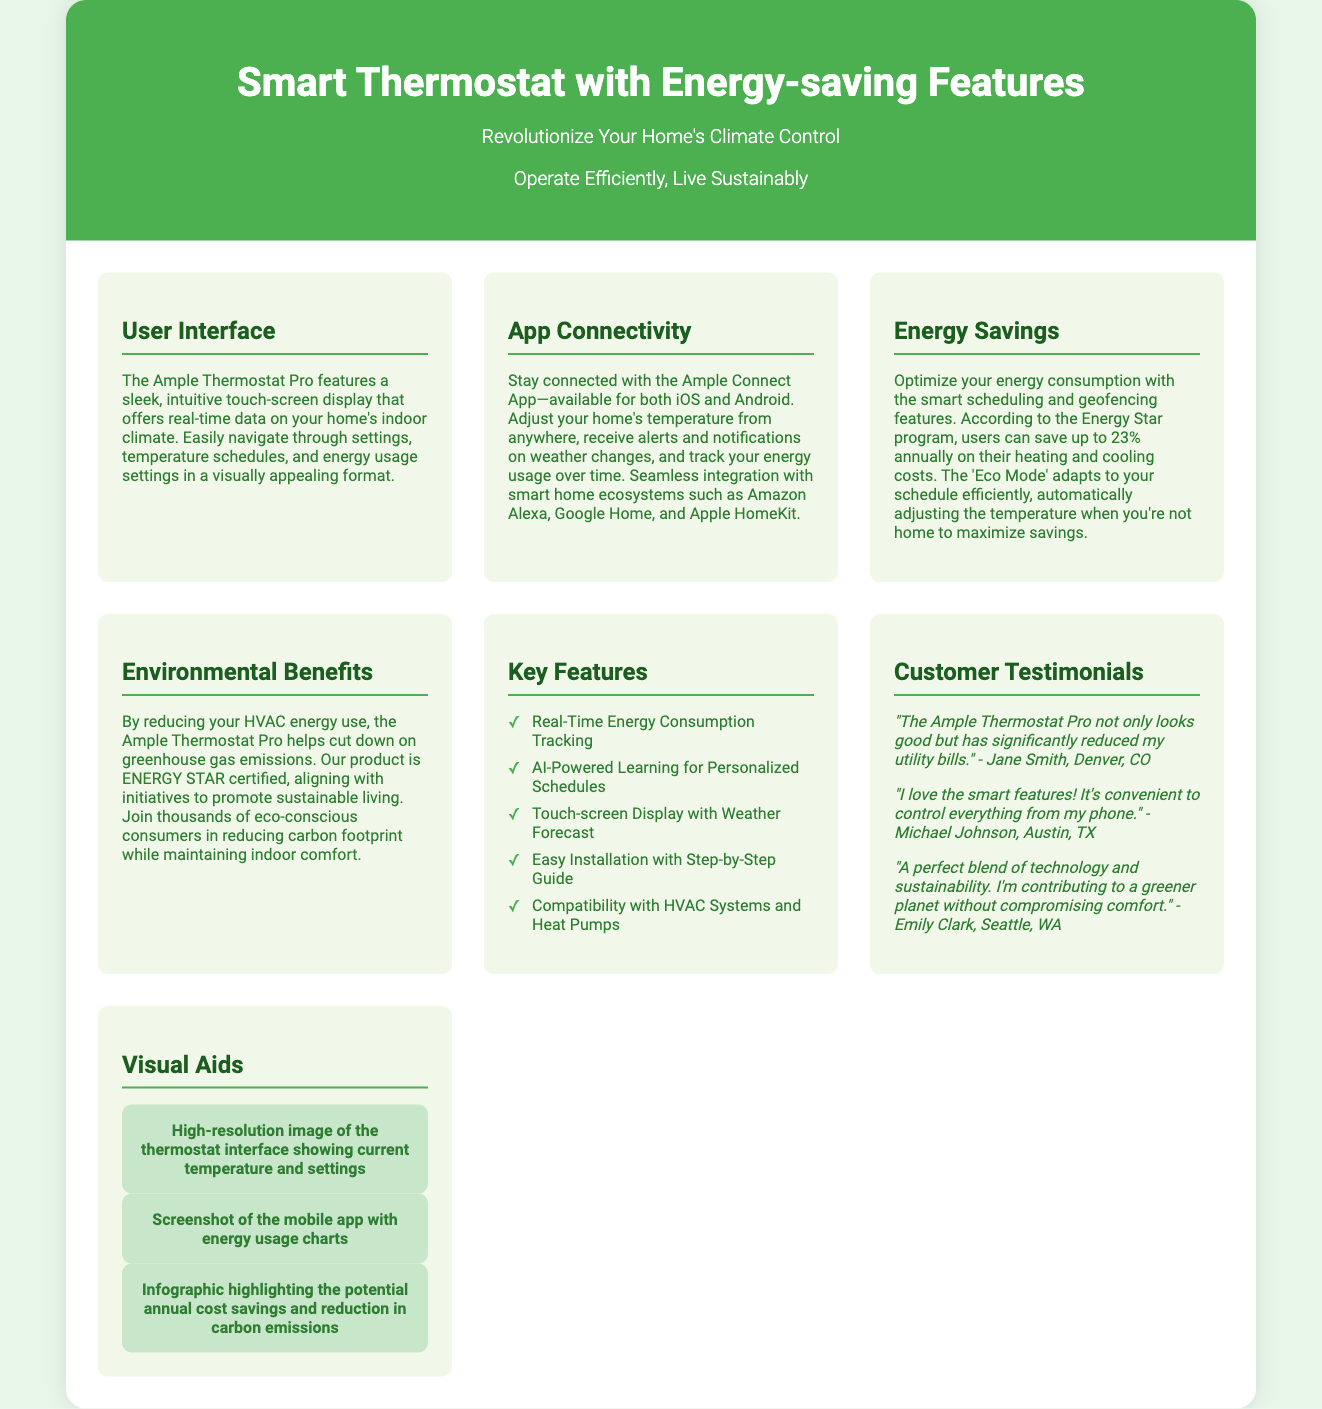What is the name of the product? The name of the product is located at the top of the document under the title.
Answer: Smart Thermostat with Energy-saving Features What mobile platforms is the app available on? The platforms for the app are mentioned in the 'App Connectivity' section.
Answer: iOS and Android How much can users save annually on heating and cooling costs? The document states specific savings related to the Energy Star program under the 'Energy Savings' section.
Answer: 23% What certification does the thermostat have? The certification is mentioned in the 'Environmental Benefits' section.
Answer: ENERGY STAR What feature enables personalized temperature scheduling? The feature responsible for personalized scheduling is mentioned in the 'Key Features' section.
Answer: AI-Powered Learning What user interface feature allows users to track energy usage? The user interface feature that offers this tracking is mentioned in the 'Energy Savings' section.
Answer: Real-Time Energy Consumption Tracking What color is used for the subsection headings? The color of the subsection headings is described in the styling of the document.
Answer: #1b5e20 What is a benefit of the 'Eco Mode'? The benefit is explained in the 'Energy Savings' section regarding temperature adjustment.
Answer: Automatically adjusting the temperature when you're not home Who is a customer that provided a testimonial? A specific customer who shared their experience is highlighted in the 'Customer Testimonials' section.
Answer: Jane Smith 